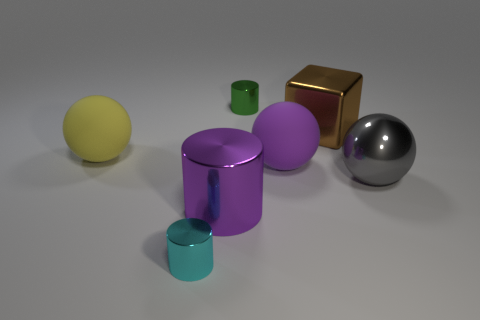Subtract all tiny metallic cylinders. How many cylinders are left? 1 Add 2 large gray objects. How many objects exist? 9 Subtract 3 cylinders. How many cylinders are left? 0 Subtract all cylinders. How many objects are left? 4 Subtract all yellow rubber balls. Subtract all gray metallic balls. How many objects are left? 5 Add 2 large gray objects. How many large gray objects are left? 3 Add 5 big brown shiny cubes. How many big brown shiny cubes exist? 6 Subtract 0 cyan spheres. How many objects are left? 7 Subtract all gray cubes. Subtract all brown cylinders. How many cubes are left? 1 